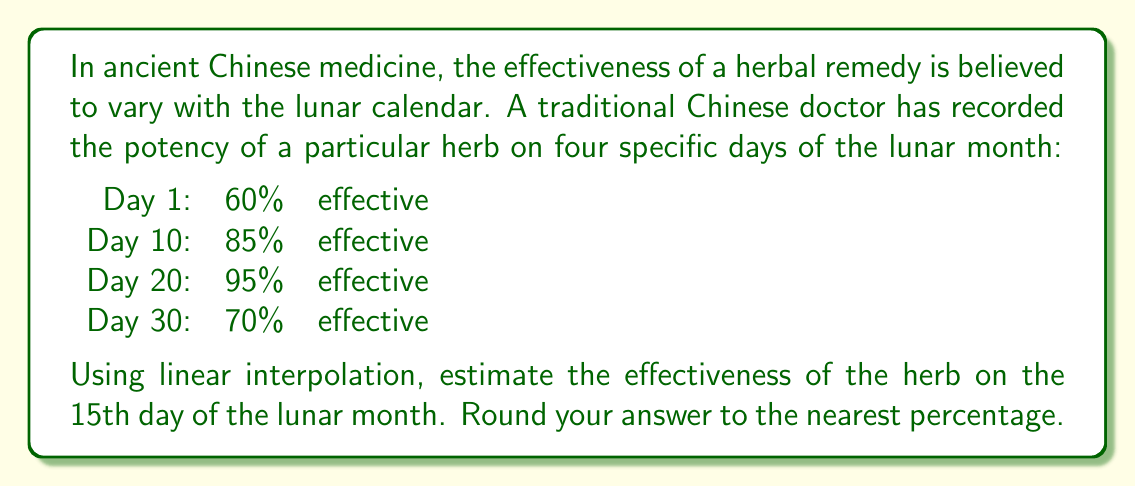Solve this math problem. To solve this problem, we will use linear interpolation between the two nearest known points. The 15th day falls between the 10th and 20th days.

1. Identify the two nearest known points:
   $x_1 = 10$, $y_1 = 85\%$
   $x_2 = 20$, $y_2 = 95\%$

2. The linear interpolation formula is:

   $$y = y_1 + \frac{(x - x_1)(y_2 - y_1)}{(x_2 - x_1)}$$

   Where $x = 15$ (the day we want to estimate)

3. Substitute the values into the formula:

   $$y = 85\% + \frac{(15 - 10)(95\% - 85\%)}{(20 - 10)}$$

4. Simplify:

   $$y = 85\% + \frac{5 \cdot 10\%}{10}$$

   $$y = 85\% + 5\%$$

   $$y = 90\%$$

Therefore, the estimated effectiveness of the herb on the 15th day of the lunar month is 90%.
Answer: 90% 